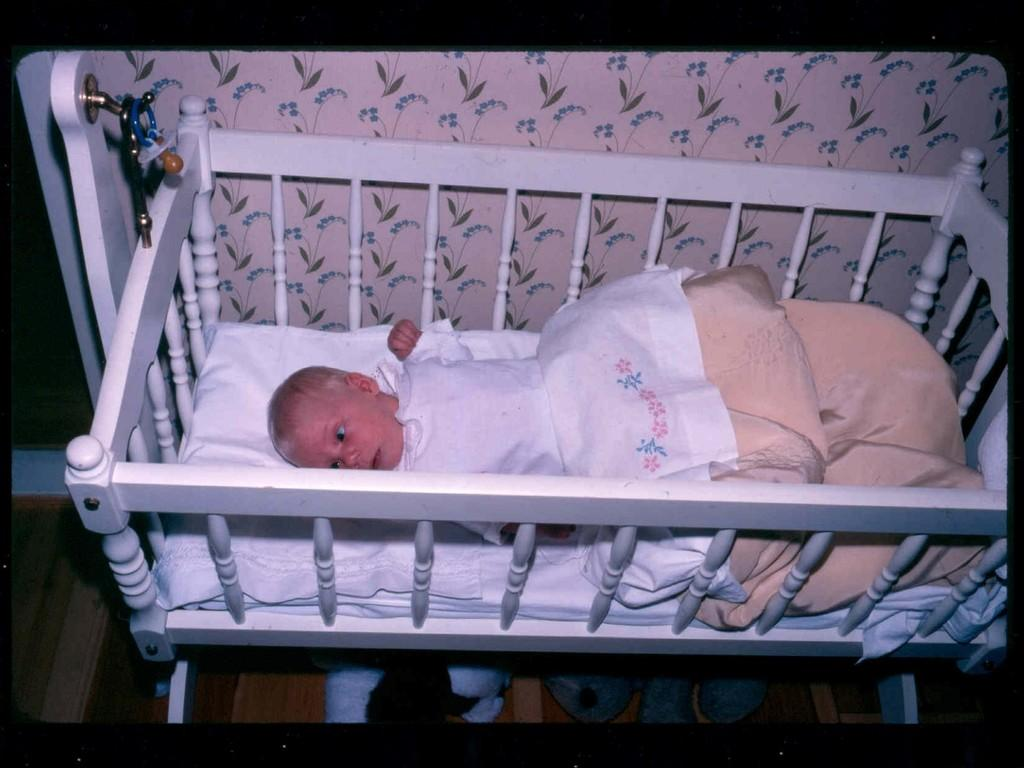What is the main subject of the image? There is a baby in the cradle. How is the baby positioned in the image? The baby is in a cradle. Is the baby covered with anything in the image? Yes, the baby is covered with a blanket. What can be seen in the background of the image? There are walls in the background of the image. What is visible beneath the cradle in the image? There is a floor visible in the image. How many tickets are visible in the image? There are no tickets present in the image. What type of ground can be seen beneath the cradle in the image? There is no ground visible in the image; it is a floor. 